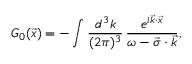Convert formula to latex. <formula><loc_0><loc_0><loc_500><loc_500>G _ { 0 } ( \vec { x } ) = - \int { \frac { d ^ { 3 } k } { ( 2 \pi ) ^ { 3 } } } \, { \frac { e ^ { i { \vec { k } \cdot \vec { x } } } } { \omega - { \vec { \sigma } \cdot \vec { k } } } } ,</formula> 